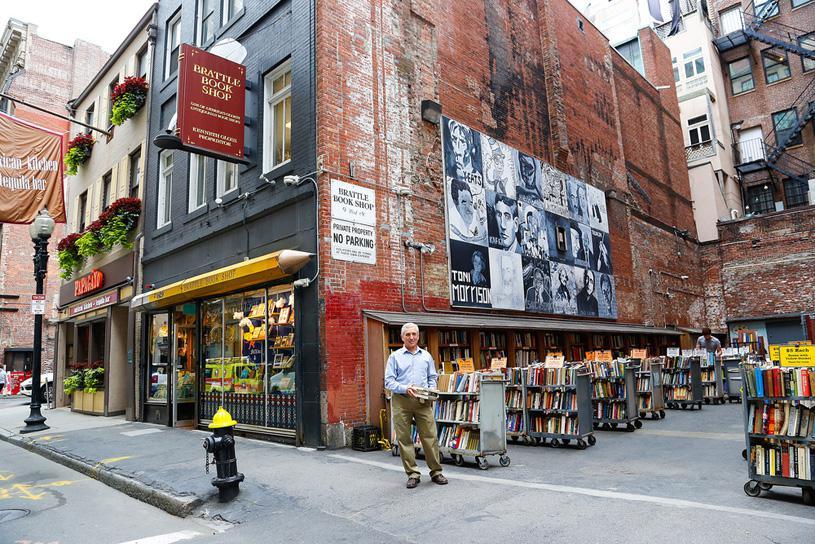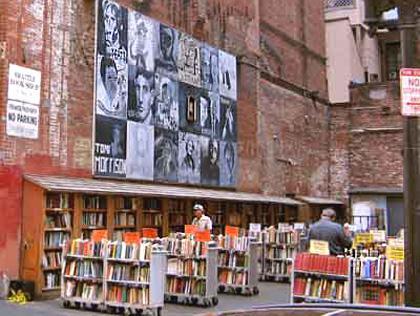The first image is the image on the left, the second image is the image on the right. Given the left and right images, does the statement "A red sign is attached and perpendicular next to a window of a dark colored building." hold true? Answer yes or no. Yes. 